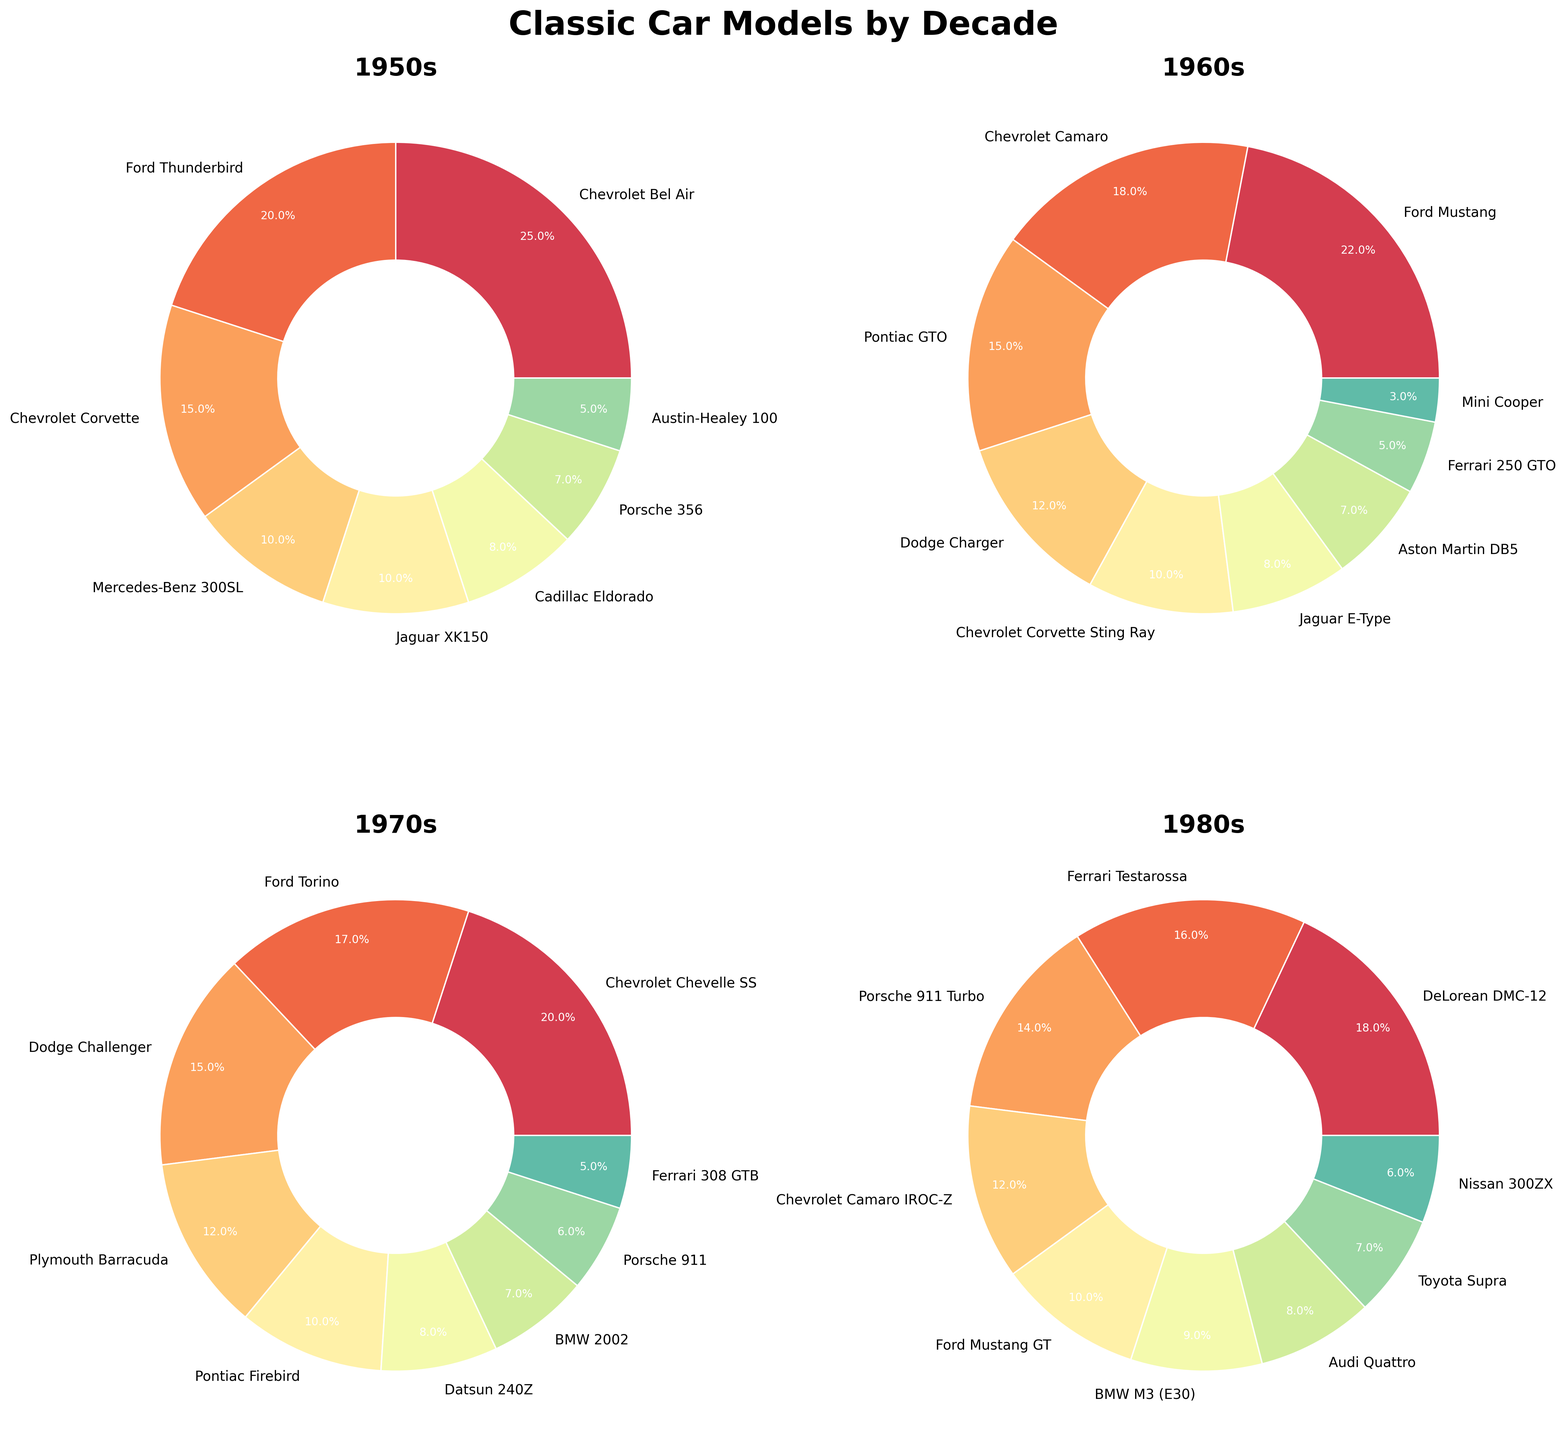Which decade features the Chevrolet Corvette Sting Ray? Look at each pie chart to determine the decade each car model belongs to. The Chevrolet Corvette Sting Ray is listed under the 1960s pie chart.
Answer: 1960s What is the total percentage covered by Ford car models across all decades? Sum the percentages of Ford Thunderbird in the 1950s (20%), Ford Mustang in the 1960s (22%), Ford Torino in the 1970s (17%), and Ford Mustang GT in the 1980s (10%).
Answer: 69% Which decade has the most evenly distributed car models by percentage? Compare the variance in percentage values across all decades. The 1950s have the most evenly distributed percentages with values like 25%, 20%, 15%, 10%, etc.
Answer: 1950s Is there a larger percentage of Chevrolet car models in the 1960s or 1970s? Compare the sum of percentages of Chevrolet models in both decades. In the 1960s, Chevrolet Camaro (18%) + Chevrolet Corvette Sting Ray (10%) = 28%. In the 1970s, Chevrolet Chevelle SS (20%).
Answer: 1960s Which car model has the smallest percentage in the 1960s pie chart? Examine the percentage labels in the 1960s pie chart to find the smallest value. The Mini Cooper has the smallest percentage, which is 3%.
Answer: Mini Cooper Which car models are represented in both the 1950s and 1960s? Identify car models that appear in both the 1950s and the 1960s pie charts. The Chevrolet Corvette appears in both decades.
Answer: Chevrolet Corvette What's the average percentage of car models in the 1970s? Sum the percentages of all car models in the 1970s and divide by the number of models: (20 + 17 + 15 + 12 + 10 + 8 + 7 + 6 + 5)/9 = 100/9 ≈ 11.1%.
Answer: ~11.1% How does the percentage of Ford Mustang in the 1980s compare to the percentage of Ford Mustang in the 1960s? Look at the percentages of the Ford Mustang in both decades. In the 1960s, it's 22%. In the 1980s, the Ford Mustang GT is 10%.
Answer: The percentage in the 1960s is higher Which decade has the highest representation of German car models? Count the German car models (BMW, Mercedes-Benz, Porsche, Audi) in each decade and compare. In the 1980s, the models include Porsche 911 Turbo, BMW M3 (E30), and Audi Quattro, totaling 3 cars.
Answer: 1980s What is the difference in percentage between the most and least popular car models in the 1950s? Identify the most and least popular models in the 1950s pie chart and subtract the least from the most. The Chevrolet Bel Air (25%) and Austin-Healey 100 (5%) give a difference of 25% - 5% = 20%.
Answer: 20% 